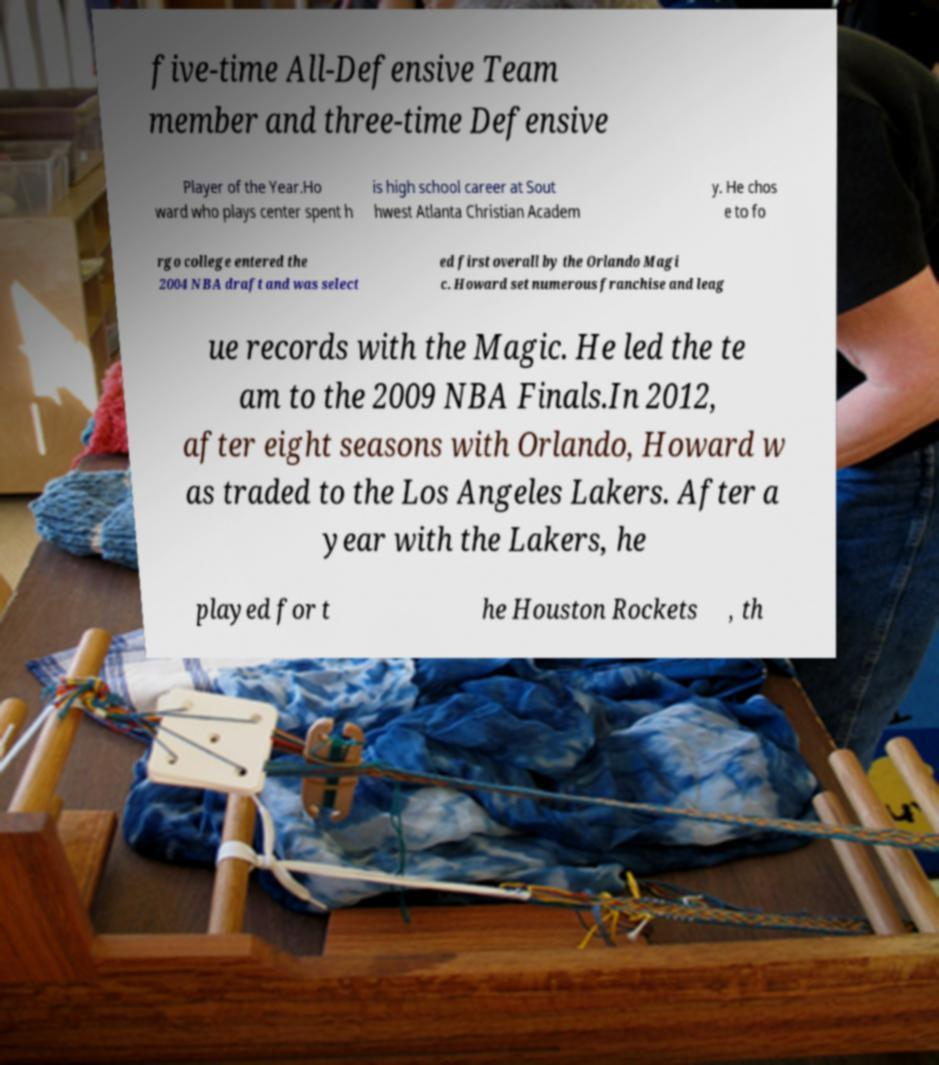Can you read and provide the text displayed in the image?This photo seems to have some interesting text. Can you extract and type it out for me? five-time All-Defensive Team member and three-time Defensive Player of the Year.Ho ward who plays center spent h is high school career at Sout hwest Atlanta Christian Academ y. He chos e to fo rgo college entered the 2004 NBA draft and was select ed first overall by the Orlando Magi c. Howard set numerous franchise and leag ue records with the Magic. He led the te am to the 2009 NBA Finals.In 2012, after eight seasons with Orlando, Howard w as traded to the Los Angeles Lakers. After a year with the Lakers, he played for t he Houston Rockets , th 